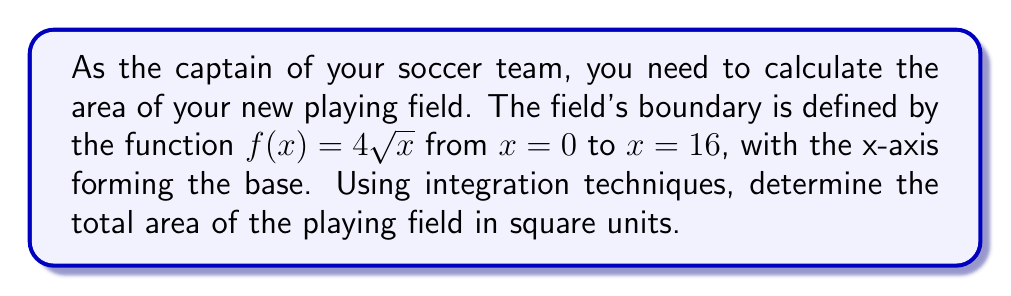Provide a solution to this math problem. Let's approach this step-by-step:

1) The area under a curve is given by the definite integral of the function. In this case, we need to integrate $f(x) = 4\sqrt{x}$ from $x = 0$ to $x = 16$.

2) Set up the integral:
   $$A = \int_0^{16} 4\sqrt{x} dx$$

3) To integrate $\sqrt{x}$, we can use the power rule with a fractional exponent:
   $\int x^n dx = \frac{x^{n+1}}{n+1} + C$ for $n \neq -1$
   
   Here, $\sqrt{x} = x^{\frac{1}{2}}$, so $n = \frac{1}{2}$

4) Apply the power rule:
   $$A = 4 \int_0^{16} x^{\frac{1}{2}} dx = 4 \cdot \frac{x^{\frac{3}{2}}}{\frac{3}{2}} \bigg|_0^{16}$$

5) Simplify:
   $$A = \frac{8}{3} x^{\frac{3}{2}} \bigg|_0^{16}$$

6) Evaluate the integral:
   $$A = \frac{8}{3} (16^{\frac{3}{2}} - 0^{\frac{3}{2}}) = \frac{8}{3} (64 - 0) = \frac{512}{3}$$

Therefore, the area of the playing field is $\frac{512}{3}$ square units.
Answer: $\frac{512}{3}$ square units 